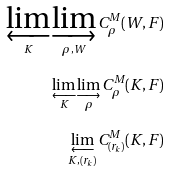<formula> <loc_0><loc_0><loc_500><loc_500>\varprojlim _ { K } \varinjlim _ { \rho , W } C ^ { M } _ { \rho } ( W , F ) \\ \varprojlim _ { K } \varinjlim _ { \rho } C ^ { M } _ { \rho } ( K , F ) \\ \varprojlim _ { K , ( r _ { k } ) } C ^ { M } _ { ( r _ { k } ) } ( K , F ) \\</formula> 